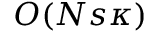Convert formula to latex. <formula><loc_0><loc_0><loc_500><loc_500>O ( N s \kappa )</formula> 